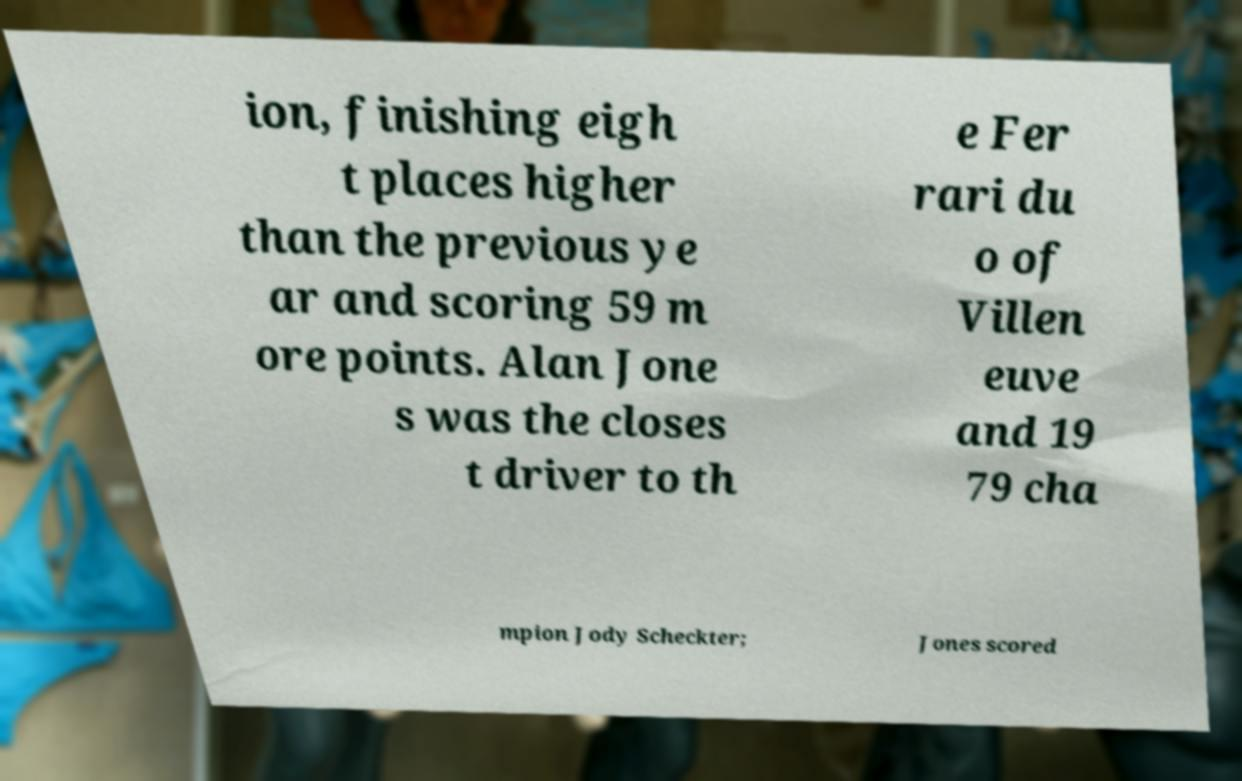Can you accurately transcribe the text from the provided image for me? ion, finishing eigh t places higher than the previous ye ar and scoring 59 m ore points. Alan Jone s was the closes t driver to th e Fer rari du o of Villen euve and 19 79 cha mpion Jody Scheckter; Jones scored 